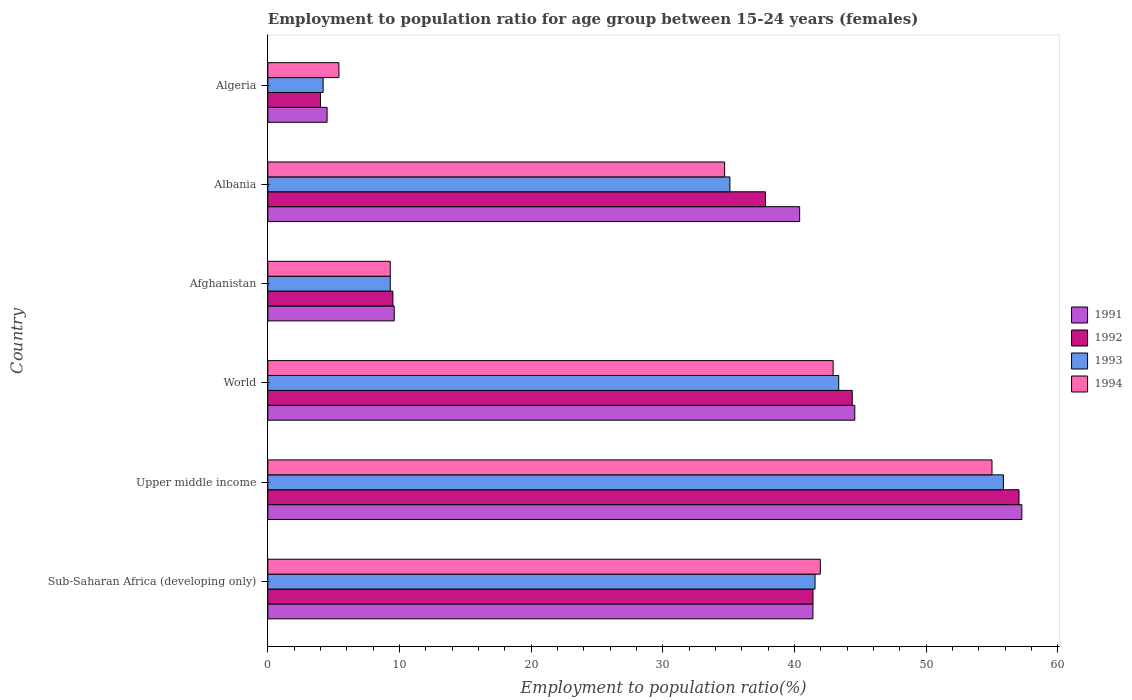How many different coloured bars are there?
Your answer should be compact. 4. How many groups of bars are there?
Your answer should be very brief. 6. Are the number of bars per tick equal to the number of legend labels?
Provide a succinct answer. Yes. How many bars are there on the 2nd tick from the top?
Provide a short and direct response. 4. How many bars are there on the 5th tick from the bottom?
Ensure brevity in your answer.  4. What is the label of the 2nd group of bars from the top?
Offer a very short reply. Albania. What is the employment to population ratio in 1994 in Albania?
Make the answer very short. 34.7. Across all countries, what is the maximum employment to population ratio in 1991?
Your response must be concise. 57.28. Across all countries, what is the minimum employment to population ratio in 1994?
Your answer should be compact. 5.4. In which country was the employment to population ratio in 1991 maximum?
Ensure brevity in your answer.  Upper middle income. In which country was the employment to population ratio in 1993 minimum?
Offer a terse response. Algeria. What is the total employment to population ratio in 1994 in the graph?
Provide a succinct answer. 189.32. What is the difference between the employment to population ratio in 1993 in Algeria and that in World?
Provide a succinct answer. -39.17. What is the difference between the employment to population ratio in 1992 in Sub-Saharan Africa (developing only) and the employment to population ratio in 1993 in Upper middle income?
Your answer should be very brief. -14.47. What is the average employment to population ratio in 1992 per country?
Keep it short and to the point. 32.36. What is the difference between the employment to population ratio in 1993 and employment to population ratio in 1991 in Albania?
Your response must be concise. -5.3. What is the ratio of the employment to population ratio in 1994 in Afghanistan to that in World?
Your answer should be very brief. 0.22. Is the difference between the employment to population ratio in 1993 in Albania and World greater than the difference between the employment to population ratio in 1991 in Albania and World?
Your response must be concise. No. What is the difference between the highest and the second highest employment to population ratio in 1992?
Provide a short and direct response. 12.67. What is the difference between the highest and the lowest employment to population ratio in 1994?
Ensure brevity in your answer.  49.61. Is the sum of the employment to population ratio in 1994 in Sub-Saharan Africa (developing only) and World greater than the maximum employment to population ratio in 1993 across all countries?
Keep it short and to the point. Yes. Is it the case that in every country, the sum of the employment to population ratio in 1992 and employment to population ratio in 1991 is greater than the sum of employment to population ratio in 1994 and employment to population ratio in 1993?
Give a very brief answer. No. What does the 4th bar from the top in Afghanistan represents?
Your answer should be very brief. 1991. Is it the case that in every country, the sum of the employment to population ratio in 1991 and employment to population ratio in 1994 is greater than the employment to population ratio in 1993?
Offer a terse response. Yes. Are the values on the major ticks of X-axis written in scientific E-notation?
Give a very brief answer. No. Does the graph contain any zero values?
Provide a succinct answer. No. Does the graph contain grids?
Give a very brief answer. No. What is the title of the graph?
Your answer should be very brief. Employment to population ratio for age group between 15-24 years (females). Does "1978" appear as one of the legend labels in the graph?
Keep it short and to the point. No. What is the label or title of the Y-axis?
Give a very brief answer. Country. What is the Employment to population ratio(%) in 1991 in Sub-Saharan Africa (developing only)?
Make the answer very short. 41.41. What is the Employment to population ratio(%) of 1992 in Sub-Saharan Africa (developing only)?
Provide a short and direct response. 41.41. What is the Employment to population ratio(%) in 1993 in Sub-Saharan Africa (developing only)?
Make the answer very short. 41.57. What is the Employment to population ratio(%) in 1994 in Sub-Saharan Africa (developing only)?
Offer a very short reply. 41.97. What is the Employment to population ratio(%) in 1991 in Upper middle income?
Ensure brevity in your answer.  57.28. What is the Employment to population ratio(%) in 1992 in Upper middle income?
Your answer should be very brief. 57.06. What is the Employment to population ratio(%) of 1993 in Upper middle income?
Your response must be concise. 55.88. What is the Employment to population ratio(%) in 1994 in Upper middle income?
Provide a succinct answer. 55.01. What is the Employment to population ratio(%) in 1991 in World?
Give a very brief answer. 44.59. What is the Employment to population ratio(%) in 1992 in World?
Offer a very short reply. 44.39. What is the Employment to population ratio(%) of 1993 in World?
Your response must be concise. 43.37. What is the Employment to population ratio(%) in 1994 in World?
Offer a terse response. 42.94. What is the Employment to population ratio(%) of 1991 in Afghanistan?
Offer a very short reply. 9.6. What is the Employment to population ratio(%) of 1993 in Afghanistan?
Give a very brief answer. 9.3. What is the Employment to population ratio(%) in 1994 in Afghanistan?
Keep it short and to the point. 9.3. What is the Employment to population ratio(%) in 1991 in Albania?
Give a very brief answer. 40.4. What is the Employment to population ratio(%) in 1992 in Albania?
Keep it short and to the point. 37.8. What is the Employment to population ratio(%) in 1993 in Albania?
Your answer should be very brief. 35.1. What is the Employment to population ratio(%) of 1994 in Albania?
Keep it short and to the point. 34.7. What is the Employment to population ratio(%) of 1992 in Algeria?
Your response must be concise. 4. What is the Employment to population ratio(%) in 1993 in Algeria?
Make the answer very short. 4.2. What is the Employment to population ratio(%) of 1994 in Algeria?
Ensure brevity in your answer.  5.4. Across all countries, what is the maximum Employment to population ratio(%) of 1991?
Your answer should be very brief. 57.28. Across all countries, what is the maximum Employment to population ratio(%) of 1992?
Ensure brevity in your answer.  57.06. Across all countries, what is the maximum Employment to population ratio(%) of 1993?
Your answer should be compact. 55.88. Across all countries, what is the maximum Employment to population ratio(%) of 1994?
Ensure brevity in your answer.  55.01. Across all countries, what is the minimum Employment to population ratio(%) in 1991?
Offer a terse response. 4.5. Across all countries, what is the minimum Employment to population ratio(%) of 1992?
Offer a very short reply. 4. Across all countries, what is the minimum Employment to population ratio(%) in 1993?
Ensure brevity in your answer.  4.2. Across all countries, what is the minimum Employment to population ratio(%) in 1994?
Offer a terse response. 5.4. What is the total Employment to population ratio(%) of 1991 in the graph?
Provide a succinct answer. 197.78. What is the total Employment to population ratio(%) in 1992 in the graph?
Provide a succinct answer. 194.17. What is the total Employment to population ratio(%) of 1993 in the graph?
Your response must be concise. 189.41. What is the total Employment to population ratio(%) in 1994 in the graph?
Keep it short and to the point. 189.32. What is the difference between the Employment to population ratio(%) of 1991 in Sub-Saharan Africa (developing only) and that in Upper middle income?
Give a very brief answer. -15.87. What is the difference between the Employment to population ratio(%) of 1992 in Sub-Saharan Africa (developing only) and that in Upper middle income?
Provide a short and direct response. -15.65. What is the difference between the Employment to population ratio(%) in 1993 in Sub-Saharan Africa (developing only) and that in Upper middle income?
Give a very brief answer. -14.31. What is the difference between the Employment to population ratio(%) of 1994 in Sub-Saharan Africa (developing only) and that in Upper middle income?
Your response must be concise. -13.04. What is the difference between the Employment to population ratio(%) in 1991 in Sub-Saharan Africa (developing only) and that in World?
Make the answer very short. -3.18. What is the difference between the Employment to population ratio(%) in 1992 in Sub-Saharan Africa (developing only) and that in World?
Make the answer very short. -2.98. What is the difference between the Employment to population ratio(%) of 1993 in Sub-Saharan Africa (developing only) and that in World?
Your answer should be compact. -1.8. What is the difference between the Employment to population ratio(%) in 1994 in Sub-Saharan Africa (developing only) and that in World?
Offer a terse response. -0.97. What is the difference between the Employment to population ratio(%) in 1991 in Sub-Saharan Africa (developing only) and that in Afghanistan?
Your response must be concise. 31.81. What is the difference between the Employment to population ratio(%) in 1992 in Sub-Saharan Africa (developing only) and that in Afghanistan?
Give a very brief answer. 31.91. What is the difference between the Employment to population ratio(%) in 1993 in Sub-Saharan Africa (developing only) and that in Afghanistan?
Ensure brevity in your answer.  32.27. What is the difference between the Employment to population ratio(%) of 1994 in Sub-Saharan Africa (developing only) and that in Afghanistan?
Ensure brevity in your answer.  32.67. What is the difference between the Employment to population ratio(%) of 1991 in Sub-Saharan Africa (developing only) and that in Albania?
Ensure brevity in your answer.  1.01. What is the difference between the Employment to population ratio(%) in 1992 in Sub-Saharan Africa (developing only) and that in Albania?
Provide a succinct answer. 3.61. What is the difference between the Employment to population ratio(%) in 1993 in Sub-Saharan Africa (developing only) and that in Albania?
Provide a short and direct response. 6.47. What is the difference between the Employment to population ratio(%) of 1994 in Sub-Saharan Africa (developing only) and that in Albania?
Make the answer very short. 7.27. What is the difference between the Employment to population ratio(%) of 1991 in Sub-Saharan Africa (developing only) and that in Algeria?
Offer a very short reply. 36.91. What is the difference between the Employment to population ratio(%) in 1992 in Sub-Saharan Africa (developing only) and that in Algeria?
Ensure brevity in your answer.  37.41. What is the difference between the Employment to population ratio(%) of 1993 in Sub-Saharan Africa (developing only) and that in Algeria?
Your answer should be compact. 37.37. What is the difference between the Employment to population ratio(%) of 1994 in Sub-Saharan Africa (developing only) and that in Algeria?
Provide a short and direct response. 36.57. What is the difference between the Employment to population ratio(%) of 1991 in Upper middle income and that in World?
Make the answer very short. 12.69. What is the difference between the Employment to population ratio(%) in 1992 in Upper middle income and that in World?
Make the answer very short. 12.67. What is the difference between the Employment to population ratio(%) of 1993 in Upper middle income and that in World?
Offer a very short reply. 12.51. What is the difference between the Employment to population ratio(%) in 1994 in Upper middle income and that in World?
Your response must be concise. 12.07. What is the difference between the Employment to population ratio(%) of 1991 in Upper middle income and that in Afghanistan?
Ensure brevity in your answer.  47.68. What is the difference between the Employment to population ratio(%) of 1992 in Upper middle income and that in Afghanistan?
Give a very brief answer. 47.56. What is the difference between the Employment to population ratio(%) in 1993 in Upper middle income and that in Afghanistan?
Ensure brevity in your answer.  46.58. What is the difference between the Employment to population ratio(%) of 1994 in Upper middle income and that in Afghanistan?
Offer a terse response. 45.71. What is the difference between the Employment to population ratio(%) in 1991 in Upper middle income and that in Albania?
Your response must be concise. 16.88. What is the difference between the Employment to population ratio(%) of 1992 in Upper middle income and that in Albania?
Ensure brevity in your answer.  19.26. What is the difference between the Employment to population ratio(%) of 1993 in Upper middle income and that in Albania?
Keep it short and to the point. 20.78. What is the difference between the Employment to population ratio(%) of 1994 in Upper middle income and that in Albania?
Your answer should be compact. 20.31. What is the difference between the Employment to population ratio(%) of 1991 in Upper middle income and that in Algeria?
Provide a succinct answer. 52.78. What is the difference between the Employment to population ratio(%) of 1992 in Upper middle income and that in Algeria?
Keep it short and to the point. 53.06. What is the difference between the Employment to population ratio(%) of 1993 in Upper middle income and that in Algeria?
Make the answer very short. 51.68. What is the difference between the Employment to population ratio(%) of 1994 in Upper middle income and that in Algeria?
Your answer should be very brief. 49.61. What is the difference between the Employment to population ratio(%) in 1991 in World and that in Afghanistan?
Provide a short and direct response. 34.99. What is the difference between the Employment to population ratio(%) of 1992 in World and that in Afghanistan?
Your response must be concise. 34.89. What is the difference between the Employment to population ratio(%) of 1993 in World and that in Afghanistan?
Your response must be concise. 34.07. What is the difference between the Employment to population ratio(%) of 1994 in World and that in Afghanistan?
Ensure brevity in your answer.  33.64. What is the difference between the Employment to population ratio(%) of 1991 in World and that in Albania?
Offer a terse response. 4.19. What is the difference between the Employment to population ratio(%) of 1992 in World and that in Albania?
Your answer should be compact. 6.59. What is the difference between the Employment to population ratio(%) in 1993 in World and that in Albania?
Your response must be concise. 8.27. What is the difference between the Employment to population ratio(%) in 1994 in World and that in Albania?
Your response must be concise. 8.24. What is the difference between the Employment to population ratio(%) of 1991 in World and that in Algeria?
Offer a terse response. 40.09. What is the difference between the Employment to population ratio(%) of 1992 in World and that in Algeria?
Keep it short and to the point. 40.39. What is the difference between the Employment to population ratio(%) in 1993 in World and that in Algeria?
Offer a very short reply. 39.17. What is the difference between the Employment to population ratio(%) in 1994 in World and that in Algeria?
Provide a succinct answer. 37.54. What is the difference between the Employment to population ratio(%) in 1991 in Afghanistan and that in Albania?
Offer a terse response. -30.8. What is the difference between the Employment to population ratio(%) in 1992 in Afghanistan and that in Albania?
Keep it short and to the point. -28.3. What is the difference between the Employment to population ratio(%) of 1993 in Afghanistan and that in Albania?
Your answer should be very brief. -25.8. What is the difference between the Employment to population ratio(%) in 1994 in Afghanistan and that in Albania?
Your response must be concise. -25.4. What is the difference between the Employment to population ratio(%) in 1991 in Afghanistan and that in Algeria?
Provide a short and direct response. 5.1. What is the difference between the Employment to population ratio(%) in 1992 in Afghanistan and that in Algeria?
Keep it short and to the point. 5.5. What is the difference between the Employment to population ratio(%) of 1993 in Afghanistan and that in Algeria?
Provide a short and direct response. 5.1. What is the difference between the Employment to population ratio(%) of 1991 in Albania and that in Algeria?
Make the answer very short. 35.9. What is the difference between the Employment to population ratio(%) in 1992 in Albania and that in Algeria?
Your response must be concise. 33.8. What is the difference between the Employment to population ratio(%) of 1993 in Albania and that in Algeria?
Provide a succinct answer. 30.9. What is the difference between the Employment to population ratio(%) of 1994 in Albania and that in Algeria?
Your answer should be compact. 29.3. What is the difference between the Employment to population ratio(%) of 1991 in Sub-Saharan Africa (developing only) and the Employment to population ratio(%) of 1992 in Upper middle income?
Make the answer very short. -15.65. What is the difference between the Employment to population ratio(%) in 1991 in Sub-Saharan Africa (developing only) and the Employment to population ratio(%) in 1993 in Upper middle income?
Make the answer very short. -14.47. What is the difference between the Employment to population ratio(%) in 1991 in Sub-Saharan Africa (developing only) and the Employment to population ratio(%) in 1994 in Upper middle income?
Make the answer very short. -13.6. What is the difference between the Employment to population ratio(%) of 1992 in Sub-Saharan Africa (developing only) and the Employment to population ratio(%) of 1993 in Upper middle income?
Your answer should be very brief. -14.47. What is the difference between the Employment to population ratio(%) of 1992 in Sub-Saharan Africa (developing only) and the Employment to population ratio(%) of 1994 in Upper middle income?
Provide a short and direct response. -13.6. What is the difference between the Employment to population ratio(%) in 1993 in Sub-Saharan Africa (developing only) and the Employment to population ratio(%) in 1994 in Upper middle income?
Keep it short and to the point. -13.44. What is the difference between the Employment to population ratio(%) in 1991 in Sub-Saharan Africa (developing only) and the Employment to population ratio(%) in 1992 in World?
Provide a short and direct response. -2.99. What is the difference between the Employment to population ratio(%) of 1991 in Sub-Saharan Africa (developing only) and the Employment to population ratio(%) of 1993 in World?
Provide a succinct answer. -1.96. What is the difference between the Employment to population ratio(%) of 1991 in Sub-Saharan Africa (developing only) and the Employment to population ratio(%) of 1994 in World?
Make the answer very short. -1.53. What is the difference between the Employment to population ratio(%) in 1992 in Sub-Saharan Africa (developing only) and the Employment to population ratio(%) in 1993 in World?
Ensure brevity in your answer.  -1.95. What is the difference between the Employment to population ratio(%) of 1992 in Sub-Saharan Africa (developing only) and the Employment to population ratio(%) of 1994 in World?
Make the answer very short. -1.53. What is the difference between the Employment to population ratio(%) of 1993 in Sub-Saharan Africa (developing only) and the Employment to population ratio(%) of 1994 in World?
Offer a terse response. -1.37. What is the difference between the Employment to population ratio(%) of 1991 in Sub-Saharan Africa (developing only) and the Employment to population ratio(%) of 1992 in Afghanistan?
Offer a very short reply. 31.91. What is the difference between the Employment to population ratio(%) of 1991 in Sub-Saharan Africa (developing only) and the Employment to population ratio(%) of 1993 in Afghanistan?
Offer a very short reply. 32.11. What is the difference between the Employment to population ratio(%) of 1991 in Sub-Saharan Africa (developing only) and the Employment to population ratio(%) of 1994 in Afghanistan?
Your response must be concise. 32.11. What is the difference between the Employment to population ratio(%) in 1992 in Sub-Saharan Africa (developing only) and the Employment to population ratio(%) in 1993 in Afghanistan?
Your answer should be very brief. 32.11. What is the difference between the Employment to population ratio(%) of 1992 in Sub-Saharan Africa (developing only) and the Employment to population ratio(%) of 1994 in Afghanistan?
Offer a very short reply. 32.11. What is the difference between the Employment to population ratio(%) in 1993 in Sub-Saharan Africa (developing only) and the Employment to population ratio(%) in 1994 in Afghanistan?
Provide a short and direct response. 32.27. What is the difference between the Employment to population ratio(%) in 1991 in Sub-Saharan Africa (developing only) and the Employment to population ratio(%) in 1992 in Albania?
Your response must be concise. 3.61. What is the difference between the Employment to population ratio(%) in 1991 in Sub-Saharan Africa (developing only) and the Employment to population ratio(%) in 1993 in Albania?
Make the answer very short. 6.31. What is the difference between the Employment to population ratio(%) of 1991 in Sub-Saharan Africa (developing only) and the Employment to population ratio(%) of 1994 in Albania?
Your answer should be compact. 6.71. What is the difference between the Employment to population ratio(%) in 1992 in Sub-Saharan Africa (developing only) and the Employment to population ratio(%) in 1993 in Albania?
Make the answer very short. 6.31. What is the difference between the Employment to population ratio(%) in 1992 in Sub-Saharan Africa (developing only) and the Employment to population ratio(%) in 1994 in Albania?
Give a very brief answer. 6.71. What is the difference between the Employment to population ratio(%) of 1993 in Sub-Saharan Africa (developing only) and the Employment to population ratio(%) of 1994 in Albania?
Provide a succinct answer. 6.87. What is the difference between the Employment to population ratio(%) of 1991 in Sub-Saharan Africa (developing only) and the Employment to population ratio(%) of 1992 in Algeria?
Your answer should be compact. 37.41. What is the difference between the Employment to population ratio(%) of 1991 in Sub-Saharan Africa (developing only) and the Employment to population ratio(%) of 1993 in Algeria?
Keep it short and to the point. 37.21. What is the difference between the Employment to population ratio(%) in 1991 in Sub-Saharan Africa (developing only) and the Employment to population ratio(%) in 1994 in Algeria?
Keep it short and to the point. 36.01. What is the difference between the Employment to population ratio(%) of 1992 in Sub-Saharan Africa (developing only) and the Employment to population ratio(%) of 1993 in Algeria?
Ensure brevity in your answer.  37.21. What is the difference between the Employment to population ratio(%) in 1992 in Sub-Saharan Africa (developing only) and the Employment to population ratio(%) in 1994 in Algeria?
Ensure brevity in your answer.  36.01. What is the difference between the Employment to population ratio(%) of 1993 in Sub-Saharan Africa (developing only) and the Employment to population ratio(%) of 1994 in Algeria?
Provide a succinct answer. 36.17. What is the difference between the Employment to population ratio(%) in 1991 in Upper middle income and the Employment to population ratio(%) in 1992 in World?
Your answer should be very brief. 12.88. What is the difference between the Employment to population ratio(%) in 1991 in Upper middle income and the Employment to population ratio(%) in 1993 in World?
Provide a succinct answer. 13.91. What is the difference between the Employment to population ratio(%) in 1991 in Upper middle income and the Employment to population ratio(%) in 1994 in World?
Give a very brief answer. 14.34. What is the difference between the Employment to population ratio(%) in 1992 in Upper middle income and the Employment to population ratio(%) in 1993 in World?
Keep it short and to the point. 13.7. What is the difference between the Employment to population ratio(%) of 1992 in Upper middle income and the Employment to population ratio(%) of 1994 in World?
Your answer should be compact. 14.12. What is the difference between the Employment to population ratio(%) of 1993 in Upper middle income and the Employment to population ratio(%) of 1994 in World?
Offer a very short reply. 12.94. What is the difference between the Employment to population ratio(%) of 1991 in Upper middle income and the Employment to population ratio(%) of 1992 in Afghanistan?
Give a very brief answer. 47.78. What is the difference between the Employment to population ratio(%) in 1991 in Upper middle income and the Employment to population ratio(%) in 1993 in Afghanistan?
Offer a terse response. 47.98. What is the difference between the Employment to population ratio(%) of 1991 in Upper middle income and the Employment to population ratio(%) of 1994 in Afghanistan?
Provide a short and direct response. 47.98. What is the difference between the Employment to population ratio(%) of 1992 in Upper middle income and the Employment to population ratio(%) of 1993 in Afghanistan?
Make the answer very short. 47.76. What is the difference between the Employment to population ratio(%) in 1992 in Upper middle income and the Employment to population ratio(%) in 1994 in Afghanistan?
Offer a terse response. 47.76. What is the difference between the Employment to population ratio(%) of 1993 in Upper middle income and the Employment to population ratio(%) of 1994 in Afghanistan?
Provide a short and direct response. 46.58. What is the difference between the Employment to population ratio(%) of 1991 in Upper middle income and the Employment to population ratio(%) of 1992 in Albania?
Provide a short and direct response. 19.48. What is the difference between the Employment to population ratio(%) of 1991 in Upper middle income and the Employment to population ratio(%) of 1993 in Albania?
Your response must be concise. 22.18. What is the difference between the Employment to population ratio(%) in 1991 in Upper middle income and the Employment to population ratio(%) in 1994 in Albania?
Offer a terse response. 22.58. What is the difference between the Employment to population ratio(%) in 1992 in Upper middle income and the Employment to population ratio(%) in 1993 in Albania?
Keep it short and to the point. 21.96. What is the difference between the Employment to population ratio(%) in 1992 in Upper middle income and the Employment to population ratio(%) in 1994 in Albania?
Make the answer very short. 22.36. What is the difference between the Employment to population ratio(%) of 1993 in Upper middle income and the Employment to population ratio(%) of 1994 in Albania?
Offer a very short reply. 21.18. What is the difference between the Employment to population ratio(%) in 1991 in Upper middle income and the Employment to population ratio(%) in 1992 in Algeria?
Your answer should be very brief. 53.28. What is the difference between the Employment to population ratio(%) of 1991 in Upper middle income and the Employment to population ratio(%) of 1993 in Algeria?
Offer a very short reply. 53.08. What is the difference between the Employment to population ratio(%) in 1991 in Upper middle income and the Employment to population ratio(%) in 1994 in Algeria?
Your response must be concise. 51.88. What is the difference between the Employment to population ratio(%) in 1992 in Upper middle income and the Employment to population ratio(%) in 1993 in Algeria?
Ensure brevity in your answer.  52.86. What is the difference between the Employment to population ratio(%) in 1992 in Upper middle income and the Employment to population ratio(%) in 1994 in Algeria?
Provide a succinct answer. 51.66. What is the difference between the Employment to population ratio(%) in 1993 in Upper middle income and the Employment to population ratio(%) in 1994 in Algeria?
Make the answer very short. 50.48. What is the difference between the Employment to population ratio(%) in 1991 in World and the Employment to population ratio(%) in 1992 in Afghanistan?
Your answer should be compact. 35.09. What is the difference between the Employment to population ratio(%) of 1991 in World and the Employment to population ratio(%) of 1993 in Afghanistan?
Your answer should be very brief. 35.29. What is the difference between the Employment to population ratio(%) in 1991 in World and the Employment to population ratio(%) in 1994 in Afghanistan?
Offer a terse response. 35.29. What is the difference between the Employment to population ratio(%) in 1992 in World and the Employment to population ratio(%) in 1993 in Afghanistan?
Keep it short and to the point. 35.09. What is the difference between the Employment to population ratio(%) in 1992 in World and the Employment to population ratio(%) in 1994 in Afghanistan?
Keep it short and to the point. 35.09. What is the difference between the Employment to population ratio(%) of 1993 in World and the Employment to population ratio(%) of 1994 in Afghanistan?
Offer a terse response. 34.07. What is the difference between the Employment to population ratio(%) of 1991 in World and the Employment to population ratio(%) of 1992 in Albania?
Offer a terse response. 6.79. What is the difference between the Employment to population ratio(%) in 1991 in World and the Employment to population ratio(%) in 1993 in Albania?
Your answer should be compact. 9.49. What is the difference between the Employment to population ratio(%) in 1991 in World and the Employment to population ratio(%) in 1994 in Albania?
Offer a terse response. 9.89. What is the difference between the Employment to population ratio(%) in 1992 in World and the Employment to population ratio(%) in 1993 in Albania?
Your answer should be compact. 9.29. What is the difference between the Employment to population ratio(%) of 1992 in World and the Employment to population ratio(%) of 1994 in Albania?
Ensure brevity in your answer.  9.69. What is the difference between the Employment to population ratio(%) in 1993 in World and the Employment to population ratio(%) in 1994 in Albania?
Offer a very short reply. 8.67. What is the difference between the Employment to population ratio(%) of 1991 in World and the Employment to population ratio(%) of 1992 in Algeria?
Your answer should be very brief. 40.59. What is the difference between the Employment to population ratio(%) in 1991 in World and the Employment to population ratio(%) in 1993 in Algeria?
Provide a succinct answer. 40.39. What is the difference between the Employment to population ratio(%) of 1991 in World and the Employment to population ratio(%) of 1994 in Algeria?
Keep it short and to the point. 39.19. What is the difference between the Employment to population ratio(%) in 1992 in World and the Employment to population ratio(%) in 1993 in Algeria?
Offer a terse response. 40.19. What is the difference between the Employment to population ratio(%) of 1992 in World and the Employment to population ratio(%) of 1994 in Algeria?
Keep it short and to the point. 38.99. What is the difference between the Employment to population ratio(%) of 1993 in World and the Employment to population ratio(%) of 1994 in Algeria?
Offer a very short reply. 37.97. What is the difference between the Employment to population ratio(%) in 1991 in Afghanistan and the Employment to population ratio(%) in 1992 in Albania?
Provide a succinct answer. -28.2. What is the difference between the Employment to population ratio(%) in 1991 in Afghanistan and the Employment to population ratio(%) in 1993 in Albania?
Your answer should be compact. -25.5. What is the difference between the Employment to population ratio(%) in 1991 in Afghanistan and the Employment to population ratio(%) in 1994 in Albania?
Your response must be concise. -25.1. What is the difference between the Employment to population ratio(%) in 1992 in Afghanistan and the Employment to population ratio(%) in 1993 in Albania?
Give a very brief answer. -25.6. What is the difference between the Employment to population ratio(%) in 1992 in Afghanistan and the Employment to population ratio(%) in 1994 in Albania?
Provide a succinct answer. -25.2. What is the difference between the Employment to population ratio(%) of 1993 in Afghanistan and the Employment to population ratio(%) of 1994 in Albania?
Provide a succinct answer. -25.4. What is the difference between the Employment to population ratio(%) of 1991 in Afghanistan and the Employment to population ratio(%) of 1992 in Algeria?
Make the answer very short. 5.6. What is the difference between the Employment to population ratio(%) of 1991 in Albania and the Employment to population ratio(%) of 1992 in Algeria?
Your answer should be very brief. 36.4. What is the difference between the Employment to population ratio(%) of 1991 in Albania and the Employment to population ratio(%) of 1993 in Algeria?
Your answer should be compact. 36.2. What is the difference between the Employment to population ratio(%) in 1991 in Albania and the Employment to population ratio(%) in 1994 in Algeria?
Provide a succinct answer. 35. What is the difference between the Employment to population ratio(%) of 1992 in Albania and the Employment to population ratio(%) of 1993 in Algeria?
Your response must be concise. 33.6. What is the difference between the Employment to population ratio(%) in 1992 in Albania and the Employment to population ratio(%) in 1994 in Algeria?
Give a very brief answer. 32.4. What is the difference between the Employment to population ratio(%) in 1993 in Albania and the Employment to population ratio(%) in 1994 in Algeria?
Your response must be concise. 29.7. What is the average Employment to population ratio(%) of 1991 per country?
Ensure brevity in your answer.  32.96. What is the average Employment to population ratio(%) of 1992 per country?
Ensure brevity in your answer.  32.36. What is the average Employment to population ratio(%) in 1993 per country?
Provide a succinct answer. 31.57. What is the average Employment to population ratio(%) in 1994 per country?
Give a very brief answer. 31.55. What is the difference between the Employment to population ratio(%) of 1991 and Employment to population ratio(%) of 1992 in Sub-Saharan Africa (developing only)?
Your answer should be very brief. -0. What is the difference between the Employment to population ratio(%) in 1991 and Employment to population ratio(%) in 1993 in Sub-Saharan Africa (developing only)?
Your answer should be compact. -0.16. What is the difference between the Employment to population ratio(%) of 1991 and Employment to population ratio(%) of 1994 in Sub-Saharan Africa (developing only)?
Make the answer very short. -0.56. What is the difference between the Employment to population ratio(%) in 1992 and Employment to population ratio(%) in 1993 in Sub-Saharan Africa (developing only)?
Your answer should be compact. -0.16. What is the difference between the Employment to population ratio(%) of 1992 and Employment to population ratio(%) of 1994 in Sub-Saharan Africa (developing only)?
Your answer should be compact. -0.56. What is the difference between the Employment to population ratio(%) of 1993 and Employment to population ratio(%) of 1994 in Sub-Saharan Africa (developing only)?
Make the answer very short. -0.4. What is the difference between the Employment to population ratio(%) of 1991 and Employment to population ratio(%) of 1992 in Upper middle income?
Your answer should be compact. 0.21. What is the difference between the Employment to population ratio(%) in 1991 and Employment to population ratio(%) in 1993 in Upper middle income?
Your answer should be very brief. 1.4. What is the difference between the Employment to population ratio(%) in 1991 and Employment to population ratio(%) in 1994 in Upper middle income?
Your answer should be very brief. 2.27. What is the difference between the Employment to population ratio(%) of 1992 and Employment to population ratio(%) of 1993 in Upper middle income?
Provide a short and direct response. 1.18. What is the difference between the Employment to population ratio(%) of 1992 and Employment to population ratio(%) of 1994 in Upper middle income?
Offer a terse response. 2.05. What is the difference between the Employment to population ratio(%) in 1993 and Employment to population ratio(%) in 1994 in Upper middle income?
Keep it short and to the point. 0.87. What is the difference between the Employment to population ratio(%) in 1991 and Employment to population ratio(%) in 1992 in World?
Keep it short and to the point. 0.19. What is the difference between the Employment to population ratio(%) in 1991 and Employment to population ratio(%) in 1993 in World?
Your answer should be very brief. 1.22. What is the difference between the Employment to population ratio(%) of 1991 and Employment to population ratio(%) of 1994 in World?
Provide a succinct answer. 1.65. What is the difference between the Employment to population ratio(%) of 1992 and Employment to population ratio(%) of 1993 in World?
Give a very brief answer. 1.03. What is the difference between the Employment to population ratio(%) in 1992 and Employment to population ratio(%) in 1994 in World?
Your answer should be compact. 1.45. What is the difference between the Employment to population ratio(%) of 1993 and Employment to population ratio(%) of 1994 in World?
Offer a terse response. 0.42. What is the difference between the Employment to population ratio(%) of 1991 and Employment to population ratio(%) of 1992 in Afghanistan?
Make the answer very short. 0.1. What is the difference between the Employment to population ratio(%) in 1991 and Employment to population ratio(%) in 1994 in Afghanistan?
Offer a terse response. 0.3. What is the difference between the Employment to population ratio(%) in 1992 and Employment to population ratio(%) in 1993 in Afghanistan?
Offer a terse response. 0.2. What is the difference between the Employment to population ratio(%) of 1992 and Employment to population ratio(%) of 1994 in Afghanistan?
Provide a succinct answer. 0.2. What is the difference between the Employment to population ratio(%) of 1991 and Employment to population ratio(%) of 1992 in Albania?
Keep it short and to the point. 2.6. What is the difference between the Employment to population ratio(%) of 1991 and Employment to population ratio(%) of 1993 in Albania?
Offer a terse response. 5.3. What is the difference between the Employment to population ratio(%) in 1991 and Employment to population ratio(%) in 1994 in Albania?
Offer a very short reply. 5.7. What is the difference between the Employment to population ratio(%) of 1992 and Employment to population ratio(%) of 1993 in Albania?
Offer a very short reply. 2.7. What is the difference between the Employment to population ratio(%) of 1991 and Employment to population ratio(%) of 1992 in Algeria?
Provide a short and direct response. 0.5. What is the difference between the Employment to population ratio(%) of 1991 and Employment to population ratio(%) of 1993 in Algeria?
Provide a short and direct response. 0.3. What is the difference between the Employment to population ratio(%) in 1991 and Employment to population ratio(%) in 1994 in Algeria?
Offer a very short reply. -0.9. What is the difference between the Employment to population ratio(%) of 1992 and Employment to population ratio(%) of 1993 in Algeria?
Offer a terse response. -0.2. What is the difference between the Employment to population ratio(%) of 1992 and Employment to population ratio(%) of 1994 in Algeria?
Your answer should be compact. -1.4. What is the difference between the Employment to population ratio(%) of 1993 and Employment to population ratio(%) of 1994 in Algeria?
Your answer should be very brief. -1.2. What is the ratio of the Employment to population ratio(%) in 1991 in Sub-Saharan Africa (developing only) to that in Upper middle income?
Offer a terse response. 0.72. What is the ratio of the Employment to population ratio(%) in 1992 in Sub-Saharan Africa (developing only) to that in Upper middle income?
Provide a succinct answer. 0.73. What is the ratio of the Employment to population ratio(%) of 1993 in Sub-Saharan Africa (developing only) to that in Upper middle income?
Keep it short and to the point. 0.74. What is the ratio of the Employment to population ratio(%) of 1994 in Sub-Saharan Africa (developing only) to that in Upper middle income?
Provide a succinct answer. 0.76. What is the ratio of the Employment to population ratio(%) in 1991 in Sub-Saharan Africa (developing only) to that in World?
Your answer should be very brief. 0.93. What is the ratio of the Employment to population ratio(%) in 1992 in Sub-Saharan Africa (developing only) to that in World?
Provide a short and direct response. 0.93. What is the ratio of the Employment to population ratio(%) of 1993 in Sub-Saharan Africa (developing only) to that in World?
Give a very brief answer. 0.96. What is the ratio of the Employment to population ratio(%) in 1994 in Sub-Saharan Africa (developing only) to that in World?
Provide a short and direct response. 0.98. What is the ratio of the Employment to population ratio(%) in 1991 in Sub-Saharan Africa (developing only) to that in Afghanistan?
Provide a short and direct response. 4.31. What is the ratio of the Employment to population ratio(%) in 1992 in Sub-Saharan Africa (developing only) to that in Afghanistan?
Your answer should be compact. 4.36. What is the ratio of the Employment to population ratio(%) in 1993 in Sub-Saharan Africa (developing only) to that in Afghanistan?
Your answer should be compact. 4.47. What is the ratio of the Employment to population ratio(%) in 1994 in Sub-Saharan Africa (developing only) to that in Afghanistan?
Give a very brief answer. 4.51. What is the ratio of the Employment to population ratio(%) in 1991 in Sub-Saharan Africa (developing only) to that in Albania?
Give a very brief answer. 1.02. What is the ratio of the Employment to population ratio(%) of 1992 in Sub-Saharan Africa (developing only) to that in Albania?
Offer a terse response. 1.1. What is the ratio of the Employment to population ratio(%) of 1993 in Sub-Saharan Africa (developing only) to that in Albania?
Offer a terse response. 1.18. What is the ratio of the Employment to population ratio(%) in 1994 in Sub-Saharan Africa (developing only) to that in Albania?
Ensure brevity in your answer.  1.21. What is the ratio of the Employment to population ratio(%) of 1991 in Sub-Saharan Africa (developing only) to that in Algeria?
Give a very brief answer. 9.2. What is the ratio of the Employment to population ratio(%) of 1992 in Sub-Saharan Africa (developing only) to that in Algeria?
Offer a terse response. 10.35. What is the ratio of the Employment to population ratio(%) of 1993 in Sub-Saharan Africa (developing only) to that in Algeria?
Your response must be concise. 9.9. What is the ratio of the Employment to population ratio(%) in 1994 in Sub-Saharan Africa (developing only) to that in Algeria?
Make the answer very short. 7.77. What is the ratio of the Employment to population ratio(%) in 1991 in Upper middle income to that in World?
Ensure brevity in your answer.  1.28. What is the ratio of the Employment to population ratio(%) in 1992 in Upper middle income to that in World?
Your answer should be very brief. 1.29. What is the ratio of the Employment to population ratio(%) of 1993 in Upper middle income to that in World?
Offer a terse response. 1.29. What is the ratio of the Employment to population ratio(%) in 1994 in Upper middle income to that in World?
Make the answer very short. 1.28. What is the ratio of the Employment to population ratio(%) in 1991 in Upper middle income to that in Afghanistan?
Provide a succinct answer. 5.97. What is the ratio of the Employment to population ratio(%) of 1992 in Upper middle income to that in Afghanistan?
Keep it short and to the point. 6.01. What is the ratio of the Employment to population ratio(%) of 1993 in Upper middle income to that in Afghanistan?
Provide a succinct answer. 6.01. What is the ratio of the Employment to population ratio(%) in 1994 in Upper middle income to that in Afghanistan?
Your response must be concise. 5.92. What is the ratio of the Employment to population ratio(%) of 1991 in Upper middle income to that in Albania?
Your response must be concise. 1.42. What is the ratio of the Employment to population ratio(%) in 1992 in Upper middle income to that in Albania?
Ensure brevity in your answer.  1.51. What is the ratio of the Employment to population ratio(%) in 1993 in Upper middle income to that in Albania?
Give a very brief answer. 1.59. What is the ratio of the Employment to population ratio(%) in 1994 in Upper middle income to that in Albania?
Offer a terse response. 1.59. What is the ratio of the Employment to population ratio(%) in 1991 in Upper middle income to that in Algeria?
Provide a short and direct response. 12.73. What is the ratio of the Employment to population ratio(%) in 1992 in Upper middle income to that in Algeria?
Provide a succinct answer. 14.27. What is the ratio of the Employment to population ratio(%) in 1993 in Upper middle income to that in Algeria?
Your answer should be very brief. 13.3. What is the ratio of the Employment to population ratio(%) of 1994 in Upper middle income to that in Algeria?
Keep it short and to the point. 10.19. What is the ratio of the Employment to population ratio(%) in 1991 in World to that in Afghanistan?
Provide a succinct answer. 4.64. What is the ratio of the Employment to population ratio(%) in 1992 in World to that in Afghanistan?
Offer a terse response. 4.67. What is the ratio of the Employment to population ratio(%) in 1993 in World to that in Afghanistan?
Your answer should be compact. 4.66. What is the ratio of the Employment to population ratio(%) of 1994 in World to that in Afghanistan?
Your response must be concise. 4.62. What is the ratio of the Employment to population ratio(%) in 1991 in World to that in Albania?
Make the answer very short. 1.1. What is the ratio of the Employment to population ratio(%) of 1992 in World to that in Albania?
Your answer should be compact. 1.17. What is the ratio of the Employment to population ratio(%) in 1993 in World to that in Albania?
Your response must be concise. 1.24. What is the ratio of the Employment to population ratio(%) in 1994 in World to that in Albania?
Make the answer very short. 1.24. What is the ratio of the Employment to population ratio(%) in 1991 in World to that in Algeria?
Your answer should be very brief. 9.91. What is the ratio of the Employment to population ratio(%) in 1992 in World to that in Algeria?
Keep it short and to the point. 11.1. What is the ratio of the Employment to population ratio(%) in 1993 in World to that in Algeria?
Provide a short and direct response. 10.33. What is the ratio of the Employment to population ratio(%) in 1994 in World to that in Algeria?
Your answer should be very brief. 7.95. What is the ratio of the Employment to population ratio(%) in 1991 in Afghanistan to that in Albania?
Offer a terse response. 0.24. What is the ratio of the Employment to population ratio(%) of 1992 in Afghanistan to that in Albania?
Offer a terse response. 0.25. What is the ratio of the Employment to population ratio(%) in 1993 in Afghanistan to that in Albania?
Give a very brief answer. 0.27. What is the ratio of the Employment to population ratio(%) in 1994 in Afghanistan to that in Albania?
Ensure brevity in your answer.  0.27. What is the ratio of the Employment to population ratio(%) of 1991 in Afghanistan to that in Algeria?
Provide a succinct answer. 2.13. What is the ratio of the Employment to population ratio(%) in 1992 in Afghanistan to that in Algeria?
Offer a very short reply. 2.38. What is the ratio of the Employment to population ratio(%) of 1993 in Afghanistan to that in Algeria?
Keep it short and to the point. 2.21. What is the ratio of the Employment to population ratio(%) of 1994 in Afghanistan to that in Algeria?
Ensure brevity in your answer.  1.72. What is the ratio of the Employment to population ratio(%) of 1991 in Albania to that in Algeria?
Offer a terse response. 8.98. What is the ratio of the Employment to population ratio(%) in 1992 in Albania to that in Algeria?
Offer a very short reply. 9.45. What is the ratio of the Employment to population ratio(%) in 1993 in Albania to that in Algeria?
Provide a short and direct response. 8.36. What is the ratio of the Employment to population ratio(%) in 1994 in Albania to that in Algeria?
Your answer should be compact. 6.43. What is the difference between the highest and the second highest Employment to population ratio(%) of 1991?
Keep it short and to the point. 12.69. What is the difference between the highest and the second highest Employment to population ratio(%) in 1992?
Give a very brief answer. 12.67. What is the difference between the highest and the second highest Employment to population ratio(%) in 1993?
Keep it short and to the point. 12.51. What is the difference between the highest and the second highest Employment to population ratio(%) in 1994?
Offer a terse response. 12.07. What is the difference between the highest and the lowest Employment to population ratio(%) of 1991?
Ensure brevity in your answer.  52.78. What is the difference between the highest and the lowest Employment to population ratio(%) in 1992?
Keep it short and to the point. 53.06. What is the difference between the highest and the lowest Employment to population ratio(%) in 1993?
Give a very brief answer. 51.68. What is the difference between the highest and the lowest Employment to population ratio(%) of 1994?
Provide a succinct answer. 49.61. 